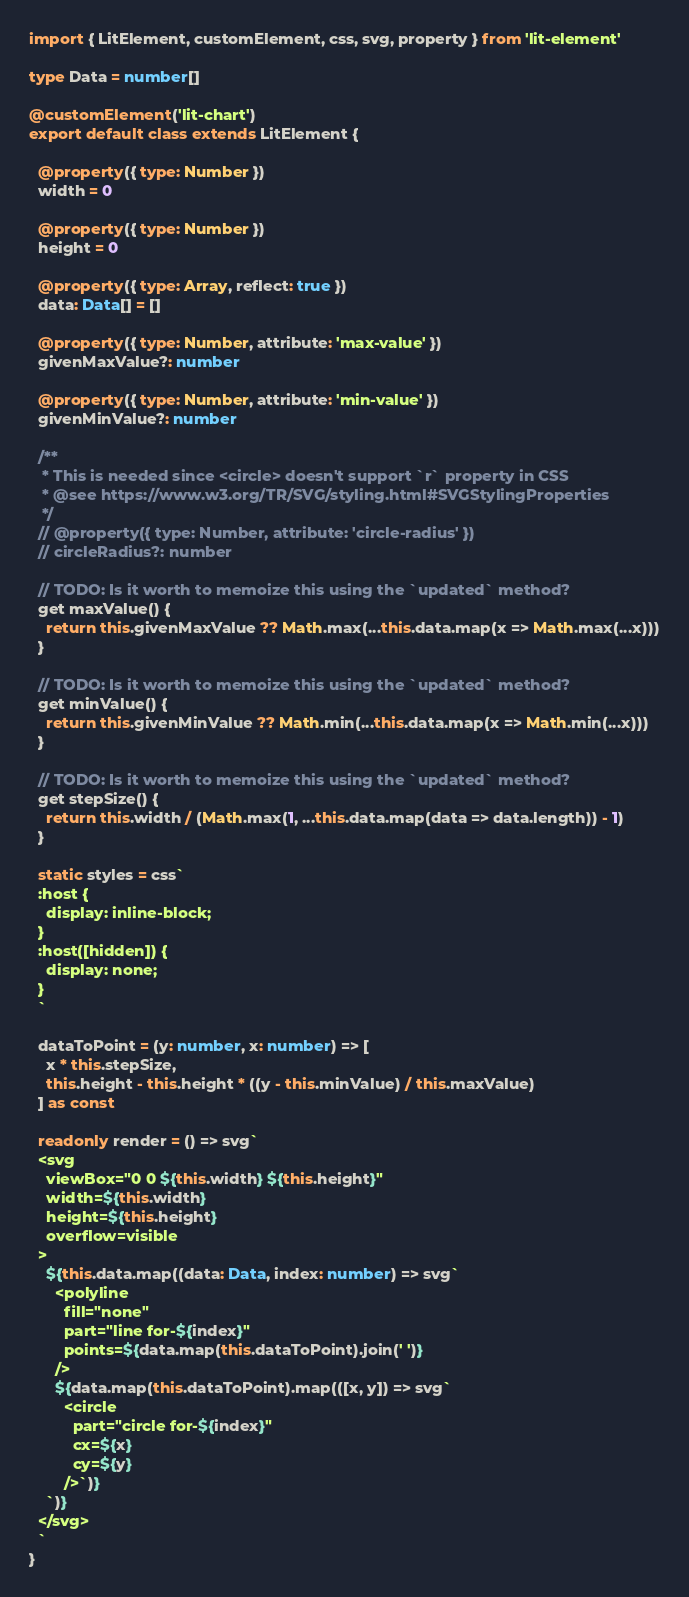Convert code to text. <code><loc_0><loc_0><loc_500><loc_500><_TypeScript_>import { LitElement, customElement, css, svg, property } from 'lit-element'

type Data = number[]

@customElement('lit-chart')
export default class extends LitElement {

  @property({ type: Number })
  width = 0

  @property({ type: Number })
  height = 0

  @property({ type: Array, reflect: true })
  data: Data[] = []

  @property({ type: Number, attribute: 'max-value' })
  givenMaxValue?: number

  @property({ type: Number, attribute: 'min-value' })
  givenMinValue?: number

  /**
   * This is needed since <circle> doesn't support `r` property in CSS
   * @see https://www.w3.org/TR/SVG/styling.html#SVGStylingProperties
   */
  // @property({ type: Number, attribute: 'circle-radius' })
  // circleRadius?: number

  // TODO: Is it worth to memoize this using the `updated` method?
  get maxValue() {
    return this.givenMaxValue ?? Math.max(...this.data.map(x => Math.max(...x)))
  }

  // TODO: Is it worth to memoize this using the `updated` method?
  get minValue() {
    return this.givenMinValue ?? Math.min(...this.data.map(x => Math.min(...x)))
  }

  // TODO: Is it worth to memoize this using the `updated` method?
  get stepSize() {
    return this.width / (Math.max(1, ...this.data.map(data => data.length)) - 1)
  }

  static styles = css`
  :host {
    display: inline-block;
  }
  :host([hidden]) {
    display: none;
  }
  `

  dataToPoint = (y: number, x: number) => [
    x * this.stepSize,
    this.height - this.height * ((y - this.minValue) / this.maxValue)
  ] as const

  readonly render = () => svg`
  <svg
    viewBox="0 0 ${this.width} ${this.height}"
    width=${this.width}
    height=${this.height}
    overflow=visible
  >
    ${this.data.map((data: Data, index: number) => svg`
      <polyline
        fill="none"
        part="line for-${index}"
        points=${data.map(this.dataToPoint).join(' ')}
      />
      ${data.map(this.dataToPoint).map(([x, y]) => svg`
        <circle
          part="circle for-${index}"
          cx=${x}
          cy=${y}
        />`)}
    `)}
  </svg>
  `
}
</code> 